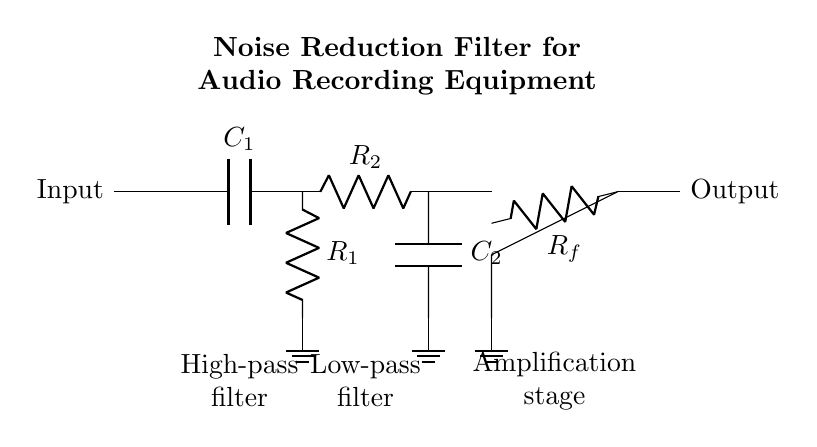What type of filter is shown in the circuit? The circuit diagram includes a high-pass filter and a low-pass filter, indicating it is a combination filter designed to reduce noise.
Answer: Combination filter What components make up the high-pass filter? The high-pass filter consists of a capacitor labeled C1 and a resistor labeled R1, which are connected in series, with one end of R1 going to ground.
Answer: C1 and R1 What is the purpose of the operational amplifier in this circuit? The operational amplifier amplifies the filtered audio signal, enhancing its strength after it has passed through the high-pass and low-pass filters.
Answer: Amplification How is the feedback for the operational amplifier configured? The feedback is provided by a resistor labeled Rf connected from the output of the operational amplifier back to its inverting input.
Answer: Rf What is the connection of the low-pass filter in relation to the high-pass filter? The low-pass filter is directly connected to the output of the high-pass filter, allowing signals that have passed through both filters to proceed to the operational amplifier.
Answer: In series What is the total number of components in this circuit? The circuit consists of four main components: two resistors (R1 and R2), two capacitors (C1 and C2), and one operational amplifier.
Answer: Four components Which part of the circuit is responsible for cutting off high-frequency noise? The high-pass filter, which consists of the capacitor C1 and resistor R1, is responsible for cutting off high-frequency noise from the signal.
Answer: High-pass filter 